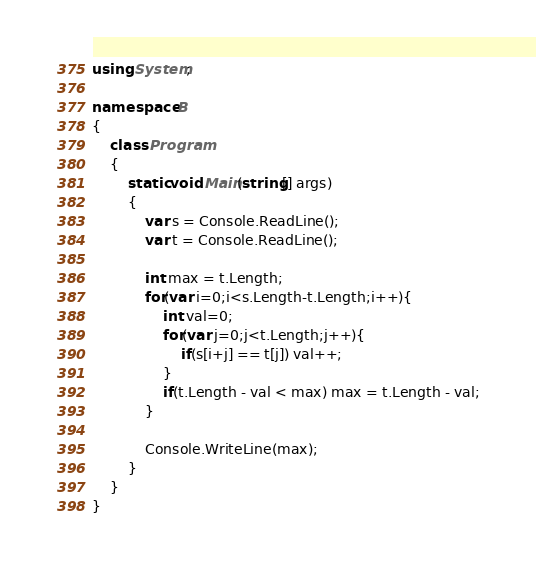<code> <loc_0><loc_0><loc_500><loc_500><_C#_>using System;

namespace B
{
    class Program
    {
        static void Main(string[] args)
        {
            var s = Console.ReadLine();
            var t = Console.ReadLine();

            int max = t.Length;
            for(var i=0;i<s.Length-t.Length;i++){
                int val=0;
                for(var j=0;j<t.Length;j++){
                    if(s[i+j] == t[j]) val++;
                }
                if(t.Length - val < max) max = t.Length - val;
            }

            Console.WriteLine(max);
        }
    }
}
</code> 